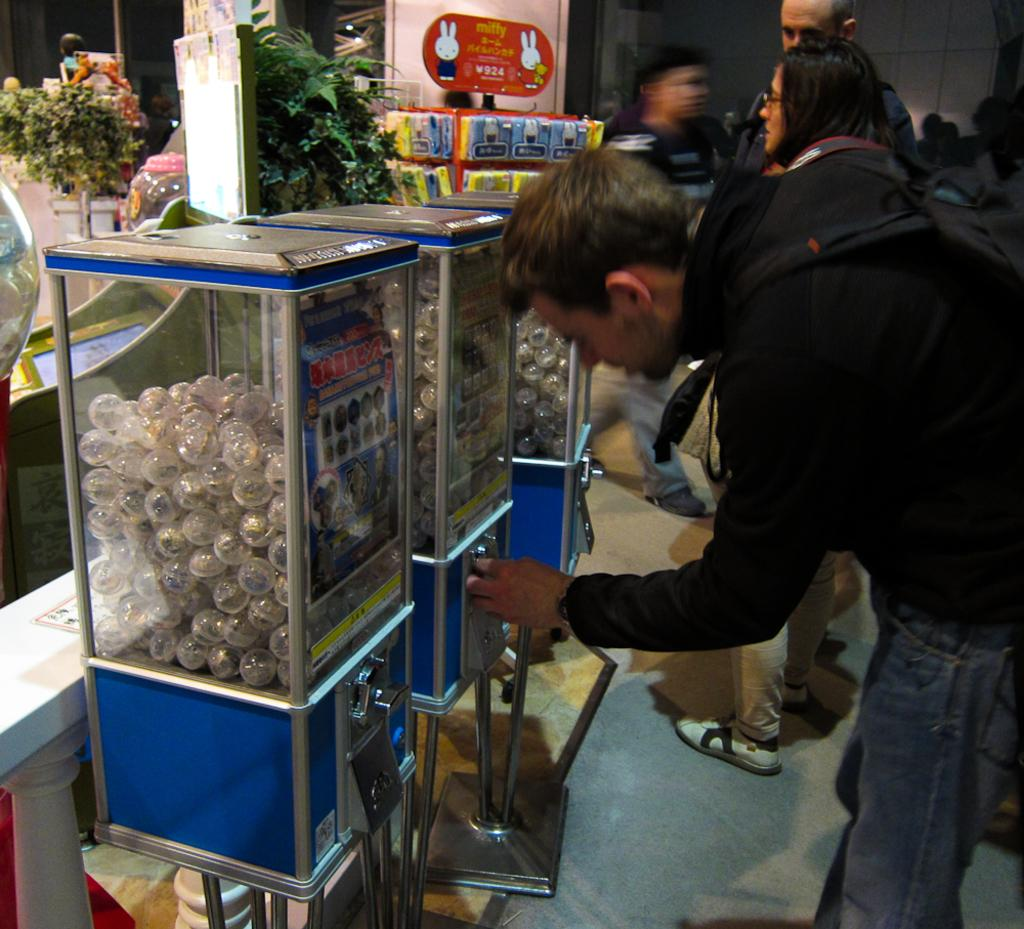What is happening in the center of the image? There are persons standing in the center of the image. What can be seen on the left side of the image? There are objects in white color inside boxes on the left side of the image. Are there any natural elements in the image? Yes, there are plants in the image. Can you tell me how many grapes are on the train in the image? There is no train present in the image, and therefore no grapes can be found on it. What type of building is visible in the image? There is no building visible in the image; it features persons standing in the center and objects in white color inside boxes on the left side. 